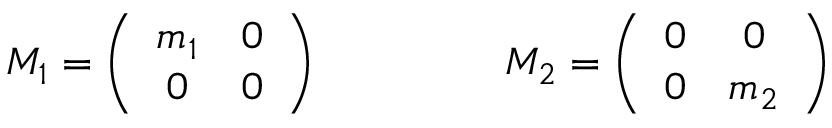Convert formula to latex. <formula><loc_0><loc_0><loc_500><loc_500>M _ { 1 } = \left ( \begin{array} { c c } { { m _ { 1 } } } & { 0 } \\ { 0 } & { 0 } \end{array} \right ) \quad \ M _ { 2 } = \left ( \begin{array} { c c } { 0 } & { 0 } \\ { 0 } & { { m _ { 2 } } } \end{array} \right )</formula> 